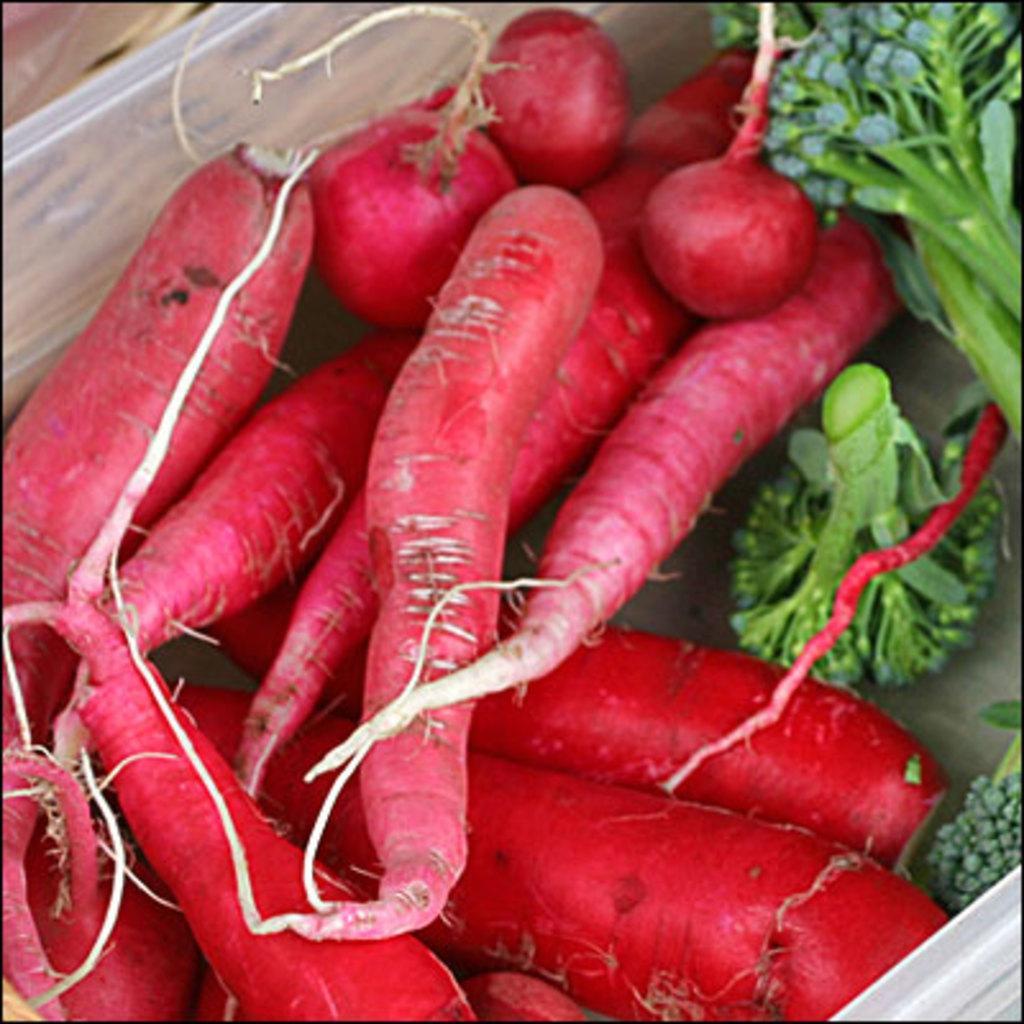How would you summarize this image in a sentence or two? In this picture I can see broccoli and few radishes. 